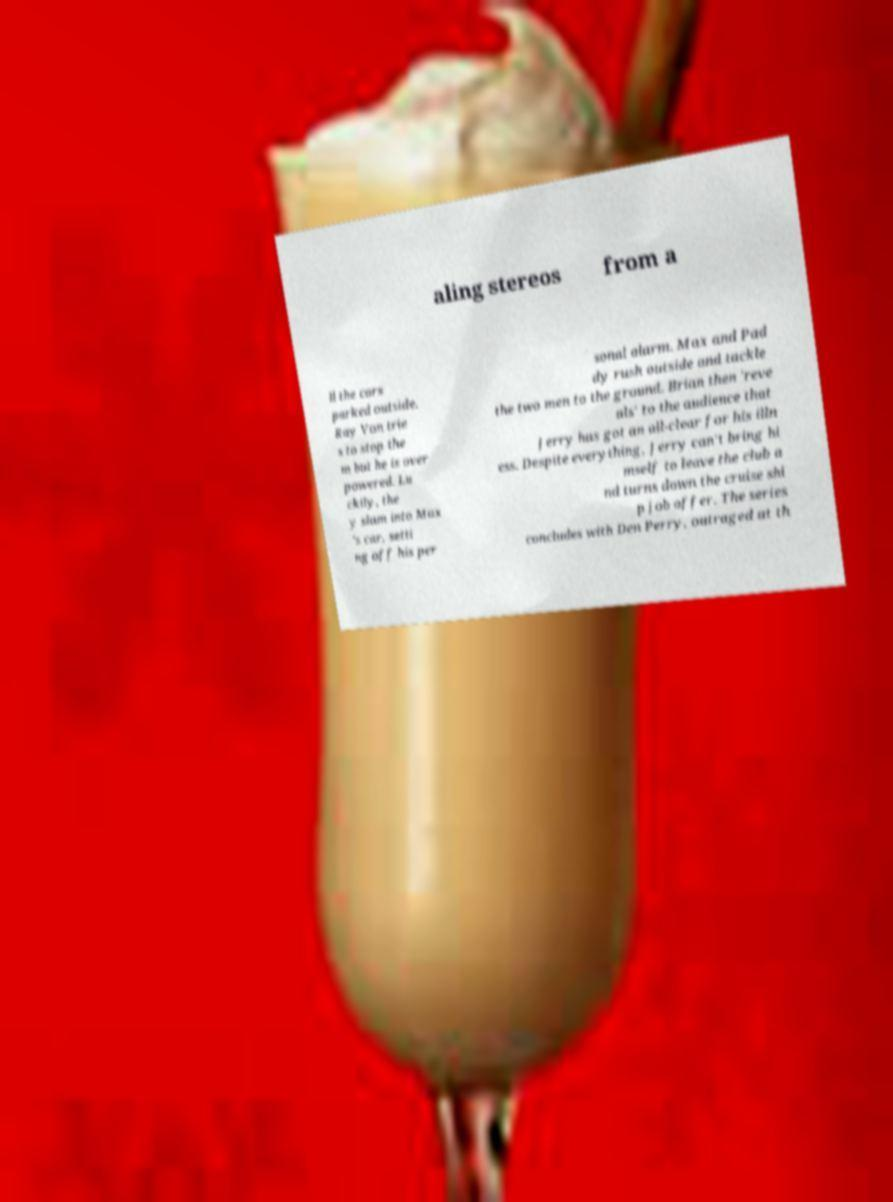Could you assist in decoding the text presented in this image and type it out clearly? aling stereos from a ll the cars parked outside. Ray Von trie s to stop the m but he is over powered. Lu ckily, the y slam into Max 's car, setti ng off his per sonal alarm. Max and Pad dy rush outside and tackle the two men to the ground. Brian then 'reve als' to the audience that Jerry has got an all-clear for his illn ess. Despite everything, Jerry can't bring hi mself to leave the club a nd turns down the cruise shi p job offer. The series concludes with Den Perry, outraged at th 